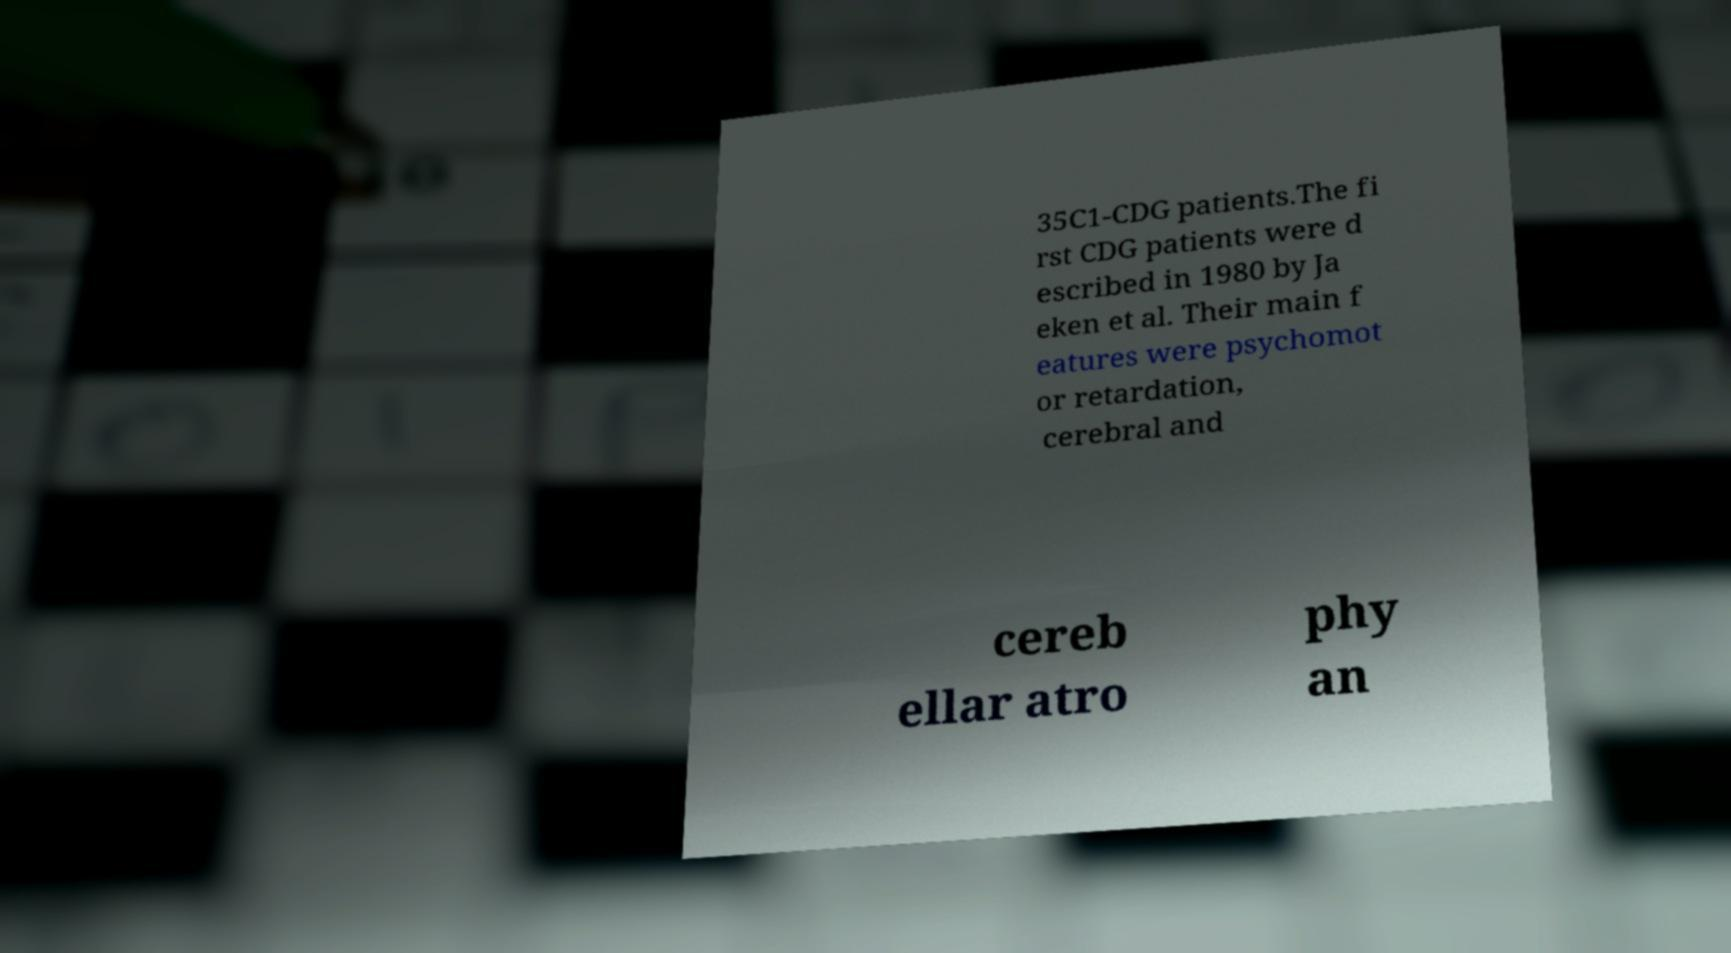For documentation purposes, I need the text within this image transcribed. Could you provide that? 35C1-CDG patients.The fi rst CDG patients were d escribed in 1980 by Ja eken et al. Their main f eatures were psychomot or retardation, cerebral and cereb ellar atro phy an 